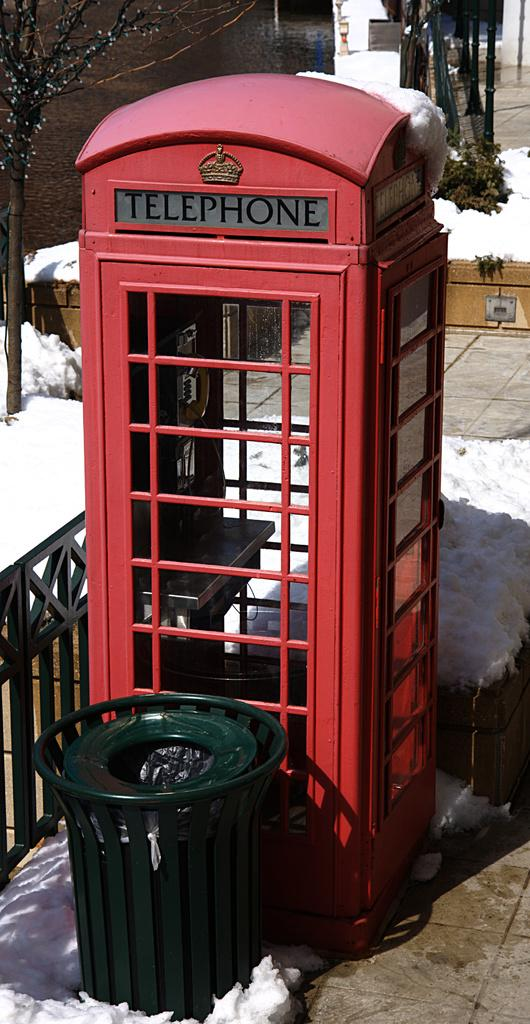<image>
Present a compact description of the photo's key features. A red telephone booth sits next to a green trash can on the street. 